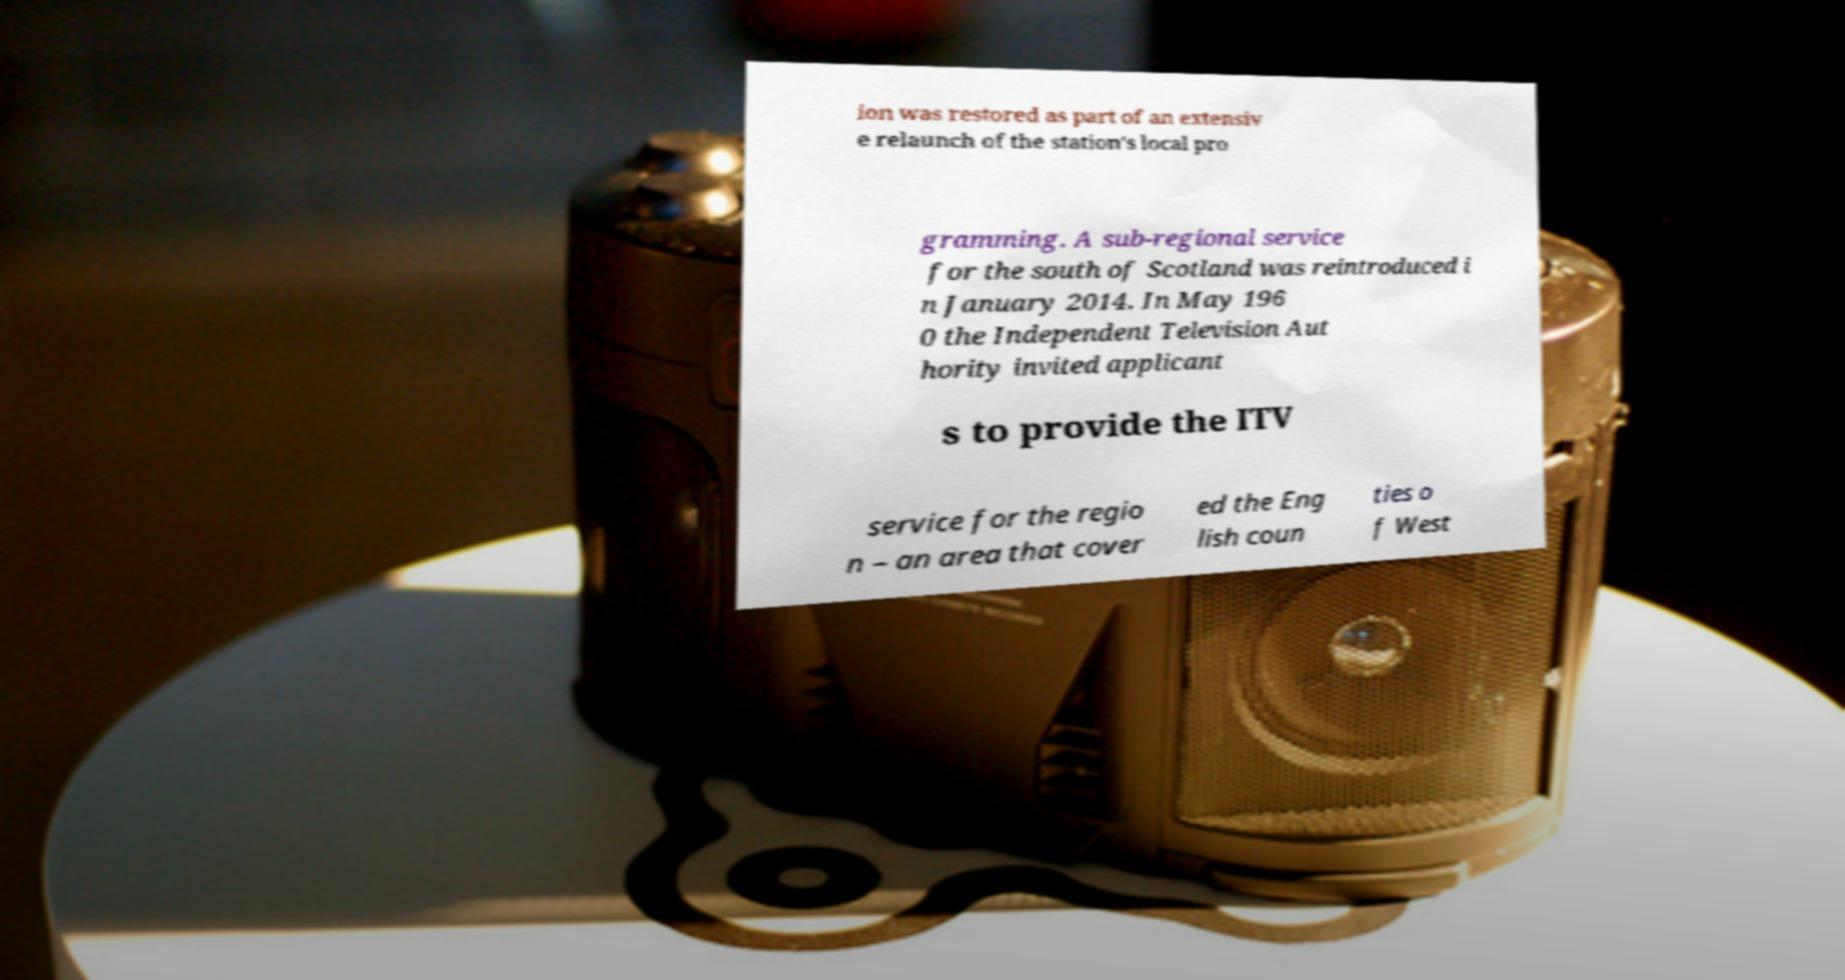I need the written content from this picture converted into text. Can you do that? ion was restored as part of an extensiv e relaunch of the station's local pro gramming. A sub-regional service for the south of Scotland was reintroduced i n January 2014. In May 196 0 the Independent Television Aut hority invited applicant s to provide the ITV service for the regio n – an area that cover ed the Eng lish coun ties o f West 